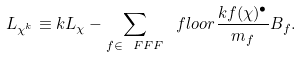<formula> <loc_0><loc_0><loc_500><loc_500>L _ { \chi ^ { k } } \equiv k L _ { \chi } - \sum _ { f \in \ F F F } \ f l o o r { \frac { k f ( \chi ) ^ { \bullet } } { m _ { f } } } B _ { f } .</formula> 